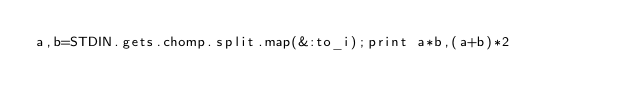Convert code to text. <code><loc_0><loc_0><loc_500><loc_500><_Ruby_>a,b=STDIN.gets.chomp.split.map(&:to_i);print a*b,(a+b)*2</code> 